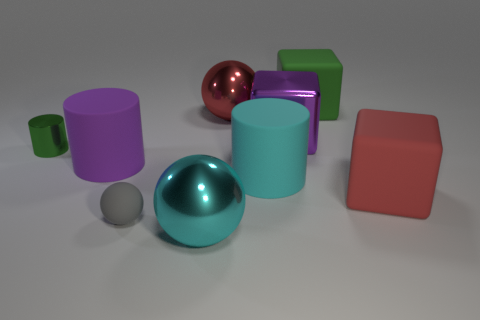Subtract all gray balls. How many balls are left? 2 Subtract 1 spheres. How many spheres are left? 2 Add 1 big purple spheres. How many objects exist? 10 Subtract all balls. How many objects are left? 6 Subtract 0 gray blocks. How many objects are left? 9 Subtract all small cylinders. Subtract all big green things. How many objects are left? 7 Add 9 green metallic cylinders. How many green metallic cylinders are left? 10 Add 2 tiny purple rubber cubes. How many tiny purple rubber cubes exist? 2 